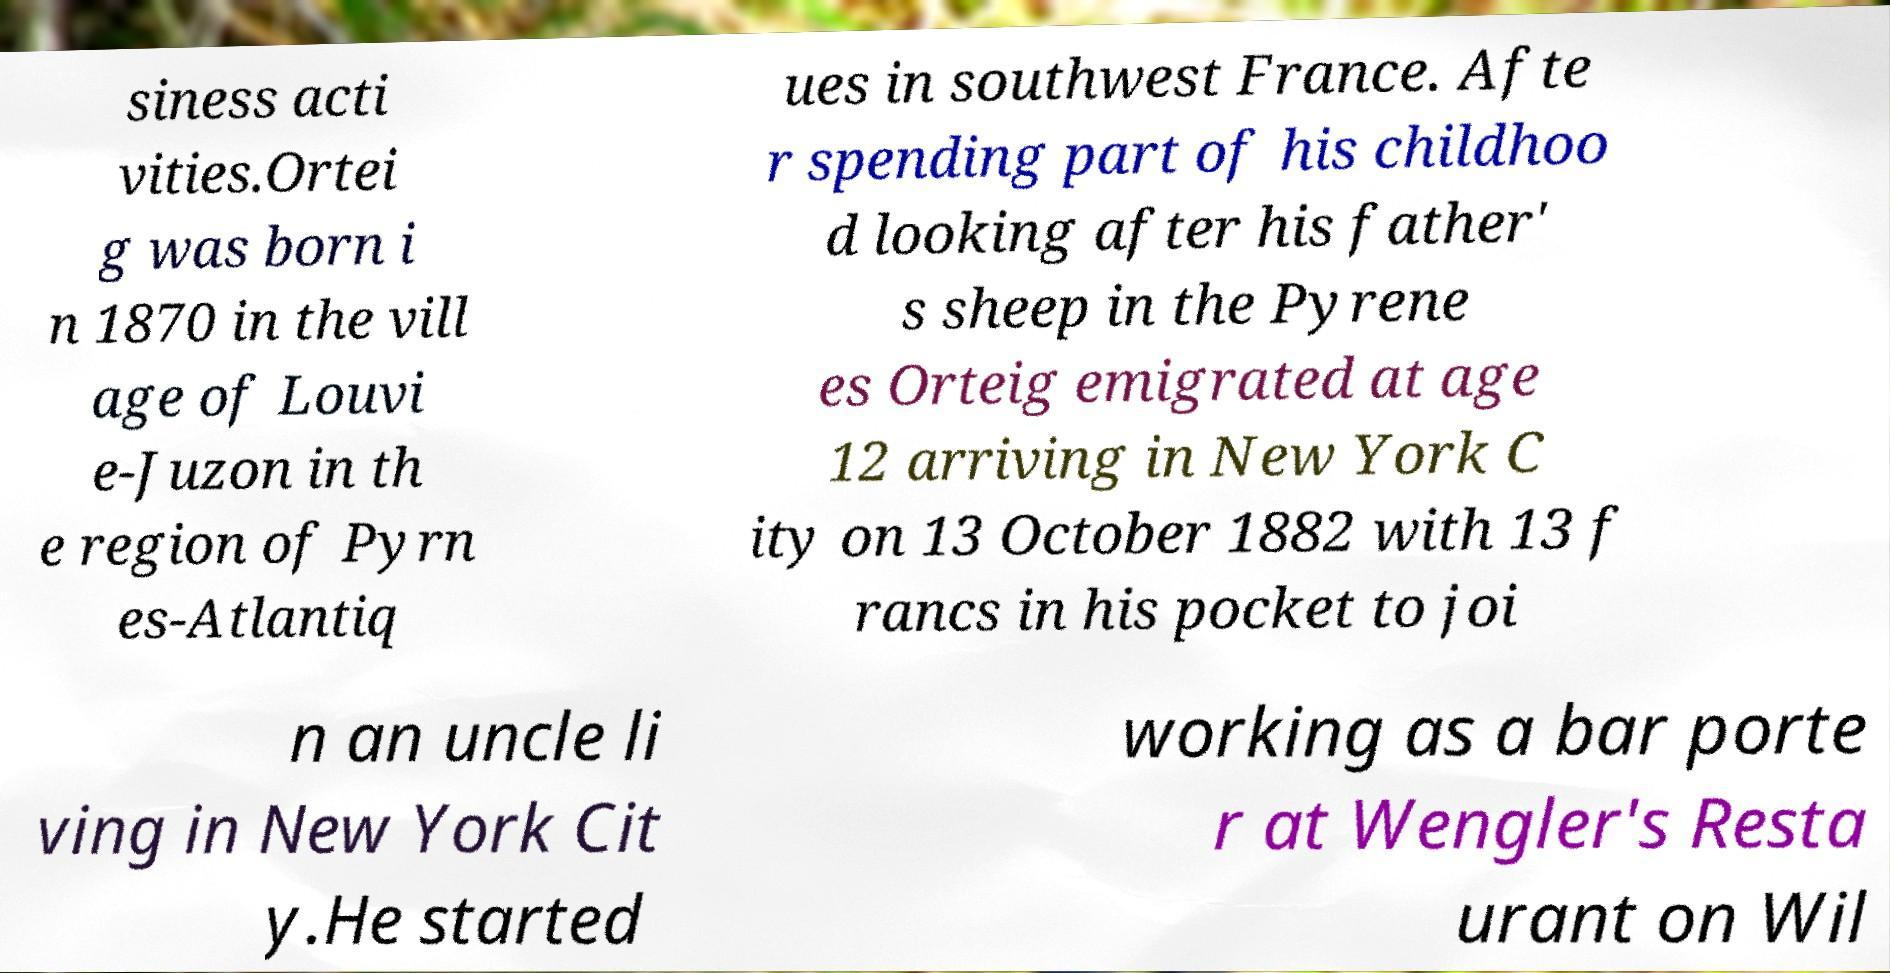There's text embedded in this image that I need extracted. Can you transcribe it verbatim? siness acti vities.Ortei g was born i n 1870 in the vill age of Louvi e-Juzon in th e region of Pyrn es-Atlantiq ues in southwest France. Afte r spending part of his childhoo d looking after his father' s sheep in the Pyrene es Orteig emigrated at age 12 arriving in New York C ity on 13 October 1882 with 13 f rancs in his pocket to joi n an uncle li ving in New York Cit y.He started working as a bar porte r at Wengler's Resta urant on Wil 